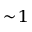Convert formula to latex. <formula><loc_0><loc_0><loc_500><loc_500>\sim \, 1</formula> 